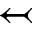<formula> <loc_0><loc_0><loc_500><loc_500>\leftarrow t a i l</formula> 